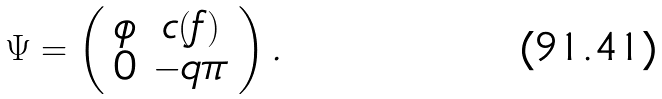Convert formula to latex. <formula><loc_0><loc_0><loc_500><loc_500>\Psi = \left ( \begin{array} { c c } \phi & c ( f ) \\ 0 & - q \pi \end{array} \right ) .</formula> 